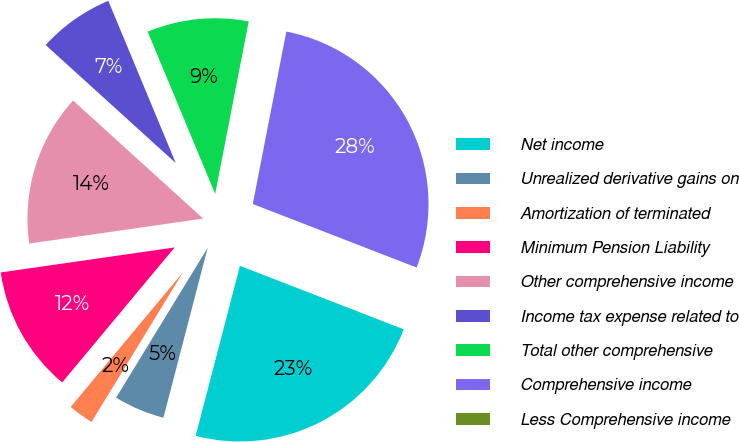<chart> <loc_0><loc_0><loc_500><loc_500><pie_chart><fcel>Net income<fcel>Unrealized derivative gains on<fcel>Amortization of terminated<fcel>Minimum Pension Liability<fcel>Other comprehensive income<fcel>Income tax expense related to<fcel>Total other comprehensive<fcel>Comprehensive income<fcel>Less Comprehensive income<nl><fcel>23.17%<fcel>4.67%<fcel>2.33%<fcel>11.67%<fcel>14.0%<fcel>7.0%<fcel>9.33%<fcel>27.83%<fcel>0.0%<nl></chart> 